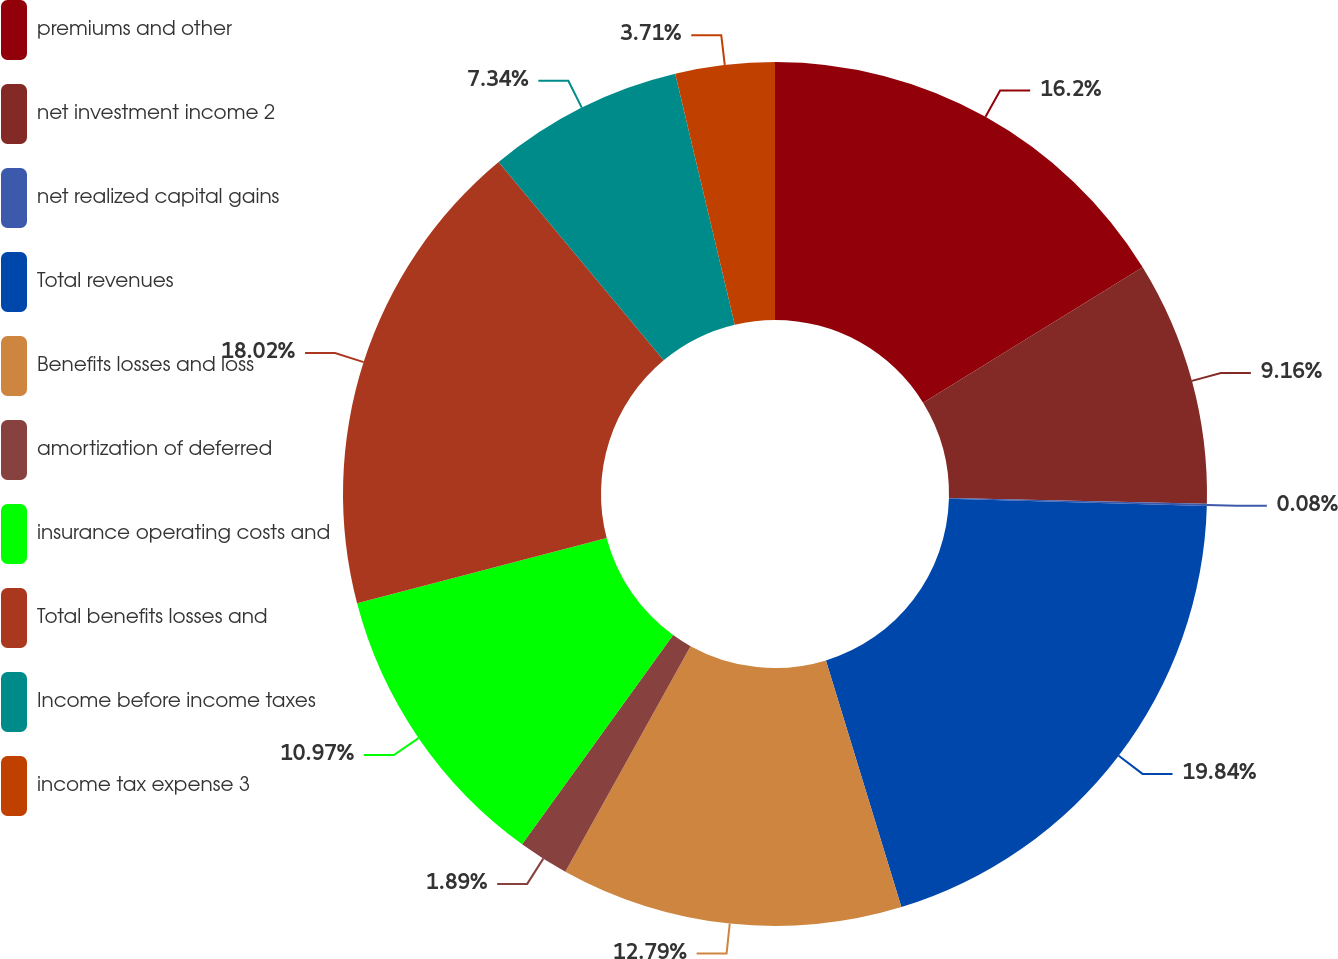<chart> <loc_0><loc_0><loc_500><loc_500><pie_chart><fcel>premiums and other<fcel>net investment income 2<fcel>net realized capital gains<fcel>Total revenues<fcel>Benefits losses and loss<fcel>amortization of deferred<fcel>insurance operating costs and<fcel>Total benefits losses and<fcel>Income before income taxes<fcel>income tax expense 3<nl><fcel>16.2%<fcel>9.16%<fcel>0.08%<fcel>19.83%<fcel>12.79%<fcel>1.89%<fcel>10.97%<fcel>18.02%<fcel>7.34%<fcel>3.71%<nl></chart> 